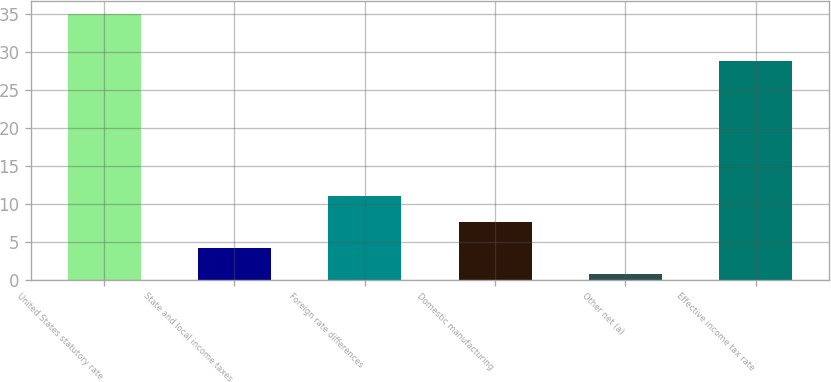Convert chart to OTSL. <chart><loc_0><loc_0><loc_500><loc_500><bar_chart><fcel>United States statutory rate<fcel>State and local income taxes<fcel>Foreign rate differences<fcel>Domestic manufacturing<fcel>Other net (a)<fcel>Effective income tax rate<nl><fcel>35<fcel>4.13<fcel>10.99<fcel>7.56<fcel>0.7<fcel>28.8<nl></chart> 